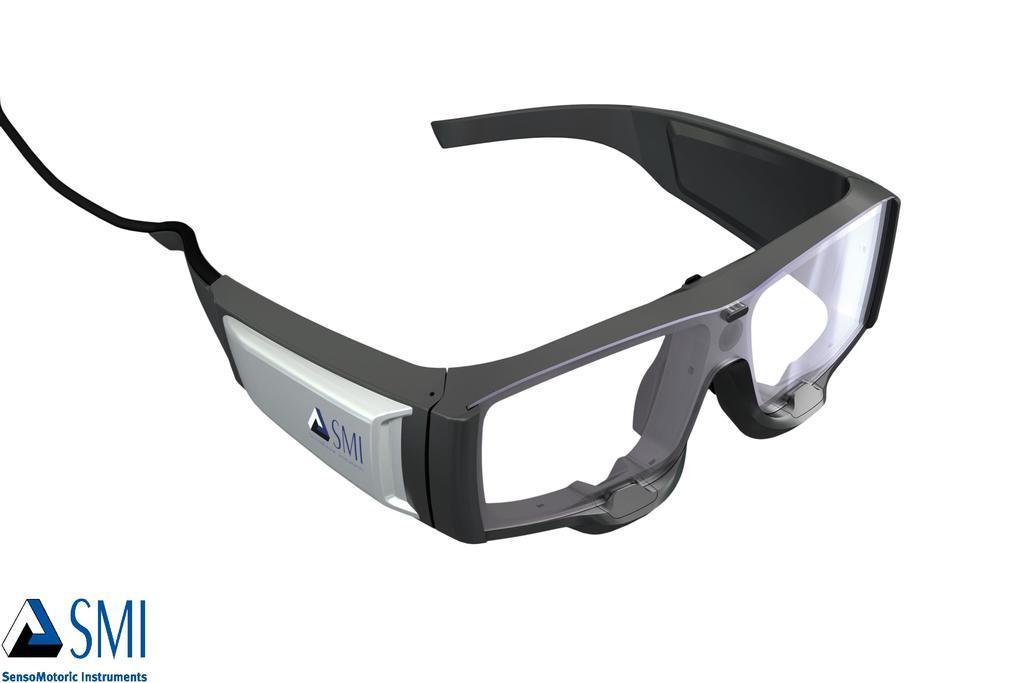Can you describe this image briefly? In this picture we can see a google. On the left we can see the company on this goggles. In bottom left corner there is a watermark. 